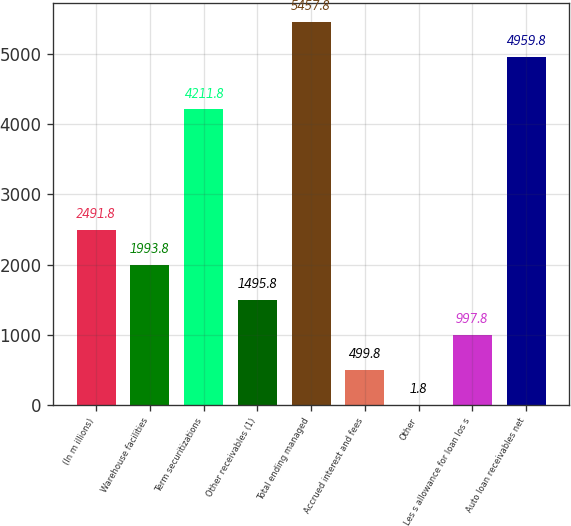Convert chart to OTSL. <chart><loc_0><loc_0><loc_500><loc_500><bar_chart><fcel>(In m illions)<fcel>Warehouse facilities<fcel>Term securitizations<fcel>Other receivables (1)<fcel>Total ending managed<fcel>Accrued interest and fees<fcel>Other<fcel>Les s allowance for loan los s<fcel>Auto loan receivables net<nl><fcel>2491.8<fcel>1993.8<fcel>4211.8<fcel>1495.8<fcel>5457.8<fcel>499.8<fcel>1.8<fcel>997.8<fcel>4959.8<nl></chart> 